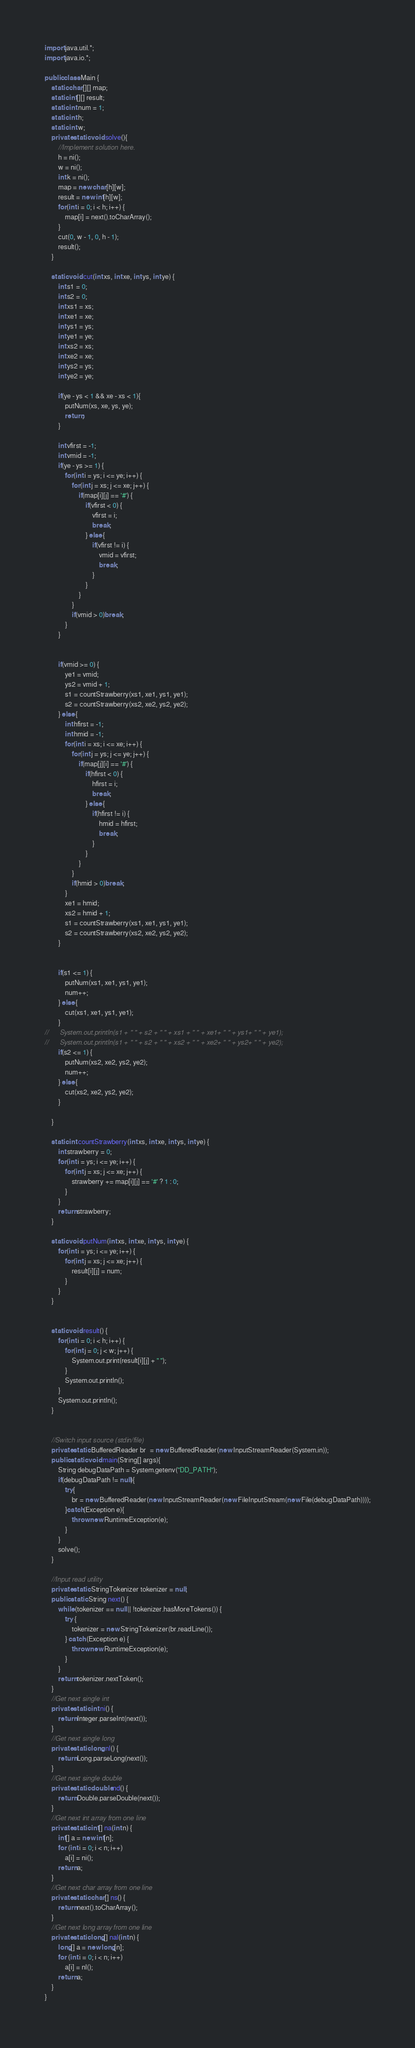<code> <loc_0><loc_0><loc_500><loc_500><_Java_>import java.util.*;
import java.io.*;

public class Main {
	static char[][] map;
	static int[][] result;
	static int num = 1;
	static int h;
	static int w;
	private static void solve(){
		//Implement solution here.
		h = ni();
		w = ni();
		int k = ni();
		map = new char[h][w];
		result = new int[h][w];
		for(int i = 0; i < h; i++) {
			map[i] = next().toCharArray();
		}
		cut(0, w - 1, 0, h - 1);
		result();
	}

	static void cut(int xs, int xe, int ys, int ye) {
		int s1 = 0;
		int s2 = 0;
		int xs1 = xs;
		int xe1 = xe;
		int ys1 = ys;
		int ye1 = ye;
		int xs2 = xs;
		int xe2 = xe;
		int ys2 = ys;
		int ye2 = ye;
		
		if(ye - ys < 1 && xe - xs < 1){
			putNum(xs, xe, ys, ye);
			return;
		}
		
		int vfirst = -1;
		int vmid = -1;
		if(ye - ys >= 1) {
			for(int i = ys; i <= ye; i++) {
				for(int j = xs; j <= xe; j++) {
					if(map[i][j] == '#') {
						if(vfirst < 0) {
							vfirst = i;
							break;
						} else {
							if(vfirst != i) {
								vmid = vfirst;
								break;
							}
						}
					}
				}
				if(vmid > 0)break;
			}
		}
		

		if(vmid >= 0) {
			ye1 = vmid;
			ys2 = vmid + 1;
			s1 = countStrawberry(xs1, xe1, ys1, ye1);
			s2 = countStrawberry(xs2, xe2, ys2, ye2);
		} else {
			int hfirst = -1;
			int hmid = -1;
			for(int i = xs; i <= xe; i++) {
				for(int j = ys; j <= ye; j++) {
					if(map[j][i] == '#') {
						if(hfirst < 0) {
							hfirst = i;
							break;
						} else {
							if(hfirst != i) {
								hmid = hfirst;
								break;
							}
						}
					}
				}
				if(hmid > 0)break;
			}
			xe1 = hmid;
			xs2 = hmid + 1;
			s1 = countStrawberry(xs1, xe1, ys1, ye1);
			s2 = countStrawberry(xs2, xe2, ys2, ye2);   
		}
		
		
		if(s1 <= 1) {
			putNum(xs1, xe1, ys1, ye1);
			num++;
		} else {
			cut(xs1, xe1, ys1, ye1);
		}
//		System.out.println(s1 + " " + s2 + " " + xs1 + " " + xe1+ " " + ys1+ " " + ye1);
//		System.out.println(s1 + " " + s2 + " " + xs2 + " " + xe2+ " " + ys2+ " " + ye2);
		if(s2 <= 1) {
			putNum(xs2, xe2, ys2, ye2); 
			num++;
		} else {			
			cut(xs2, xe2, ys2, ye2);
		}

	}

	static int countStrawberry(int xs, int xe, int ys, int ye) {
		int strawberry = 0;
		for(int i = ys; i <= ye; i++) {
			for(int j = xs; j <= xe; j++) {
				strawberry += map[i][j] == '#' ? 1 : 0;
			}
		}
		return strawberry;    	
	}

	static void putNum(int xs, int xe, int ys, int ye) {
		for(int i = ys; i <= ye; i++) {
			for(int j = xs; j <= xe; j++) {
				result[i][j] = num;
			}
		}
	}


	static void result() {
		for(int i = 0; i < h; i++) {
			for(int j = 0; j < w; j++) {
				System.out.print(result[i][j] + " ");
			}
			System.out.println();
		}
		System.out.println();
	}


	//Switch input source (stdin/file)
	private static BufferedReader br  = new BufferedReader(new InputStreamReader(System.in));
	public static void main(String[] args){
		String debugDataPath = System.getenv("DD_PATH");        
		if(debugDataPath != null){
			try{
				br = new BufferedReader(new InputStreamReader(new FileInputStream(new File(debugDataPath))));
			}catch(Exception e){
				throw new RuntimeException(e);
			}
		}
		solve();
	}

	//Input read utility
	private static StringTokenizer tokenizer = null;
	public static String next() {
		while (tokenizer == null || !tokenizer.hasMoreTokens()) {
			try {
				tokenizer = new StringTokenizer(br.readLine());
			} catch (Exception e) {
				throw new RuntimeException(e);
			}
		}
		return tokenizer.nextToken();
	}
	//Get next single int
	private static int ni() {
		return Integer.parseInt(next());
	}
	//Get next single long
	private static long nl() {
		return Long.parseLong(next());
	}
	//Get next single double
	private static double nd() {
		return Double.parseDouble(next());
	}
	//Get next int array from one line
	private static int[] na(int n) {
		int[] a = new int[n];
		for (int i = 0; i < n; i++)
			a[i] = ni();
		return a;
	}
	//Get next char array from one line
	private static char[] ns() {
		return next().toCharArray();
	}
	//Get next long array from one line
	private static long[] nal(int n) {
		long[] a = new long[n];
		for (int i = 0; i < n; i++)
			a[i] = nl();
		return a;
	}
}</code> 